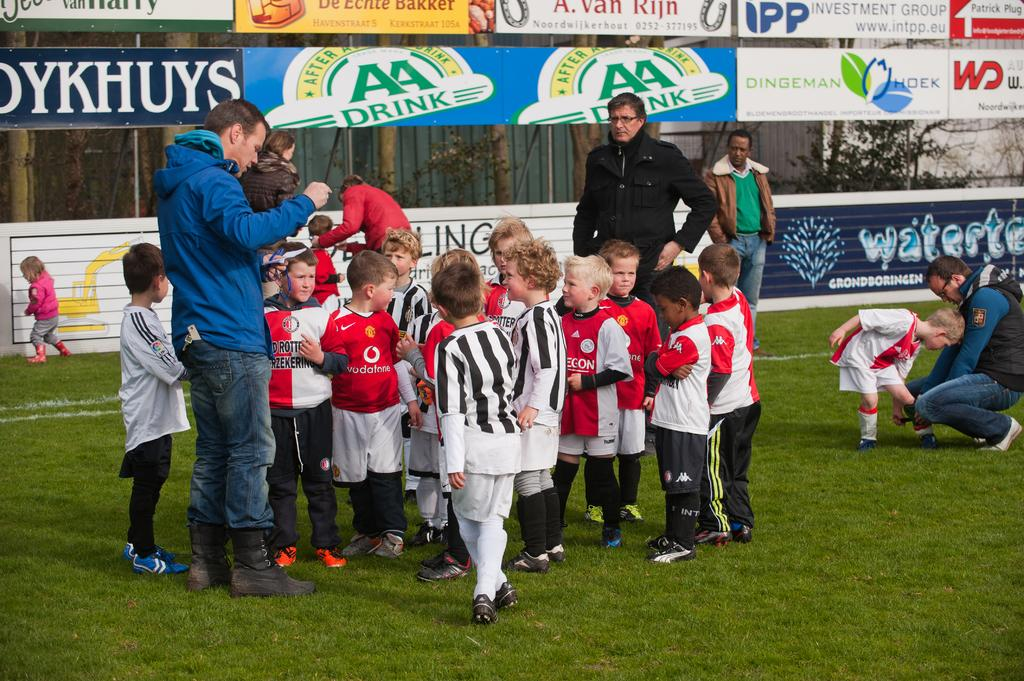What is visible beneath the people in the image? There is ground visible in the image. What are the people doing on the ground? There are people standing on the ground. What can be seen in the background of the image? There are banners, trees, and buildings in the background of the image. What type of spoon can be seen sparking in the image? There is no spoon or spark present in the image. 